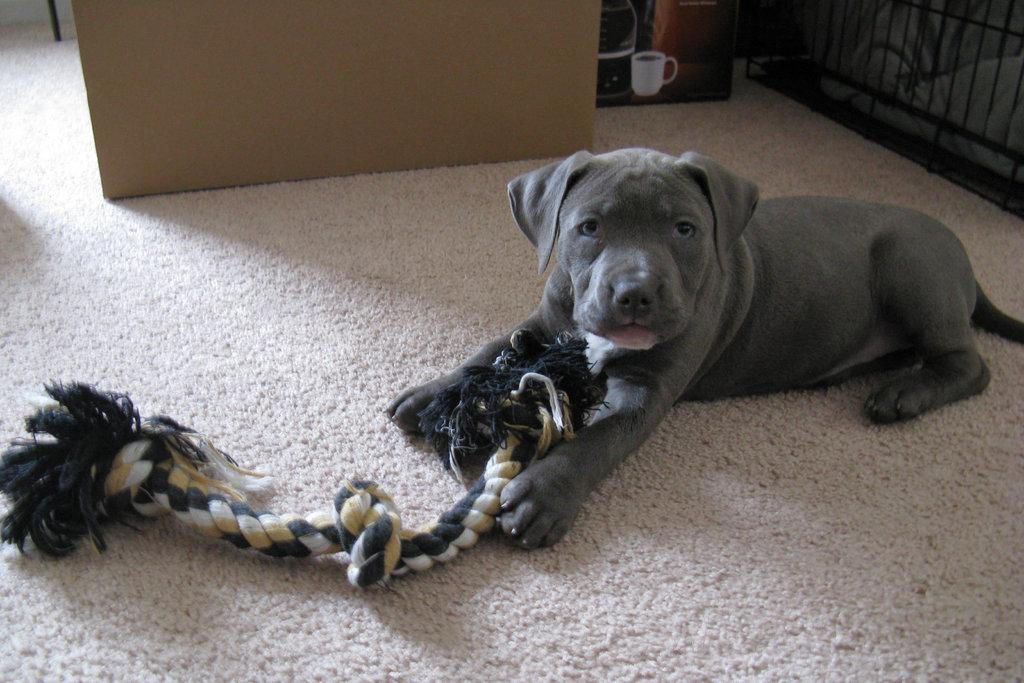What type of animal is on the carpet in the image? There is a dog on the carpet in the image. What object is also on the carpet? There is a rope on the carpet. Where is the cup located in the image? The cup is on a box in the image. Can you see a snail crawling on the dog in the image? There is no snail present in the image; it only features a dog and a rope on the carpet. 